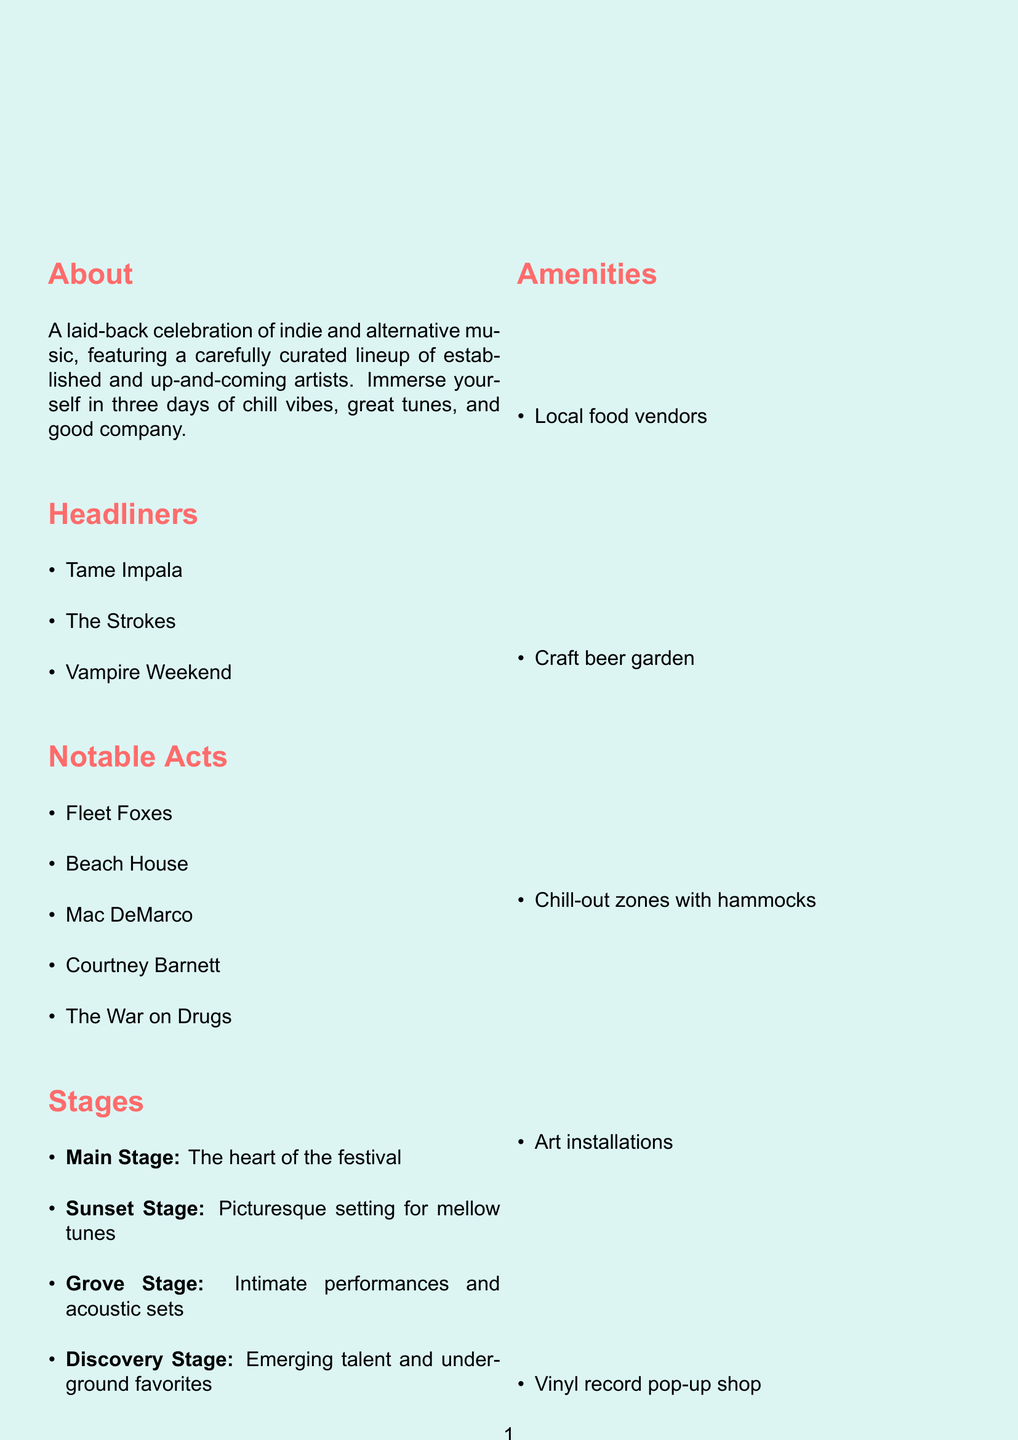what are the dates of the festival? The festival takes place from August 15-17, 2023.
Answer: August 15-17, 2023 what is the location of the festival? The festival is held at Harmony Park, Austin, TX.
Answer: Harmony Park, Austin, TX who are the headliners? The main acts featured at the festival include Tame Impala, The Strokes, and Vampire Weekend.
Answer: Tame Impala, The Strokes, Vampire Weekend how many stages are there? There are four stages at the festival, as listed in the document.
Answer: Four what is the general ticket price? The general ticket price is provided in the document.
Answer: $199 what is an example of a sustainability initiative at the festival? Several sustainability initiatives are mentioned, one of which is the reusable cup program.
Answer: Reusable cup program which stage features intimate performances? The Grove Stage is described as perfect for intimate performances and acoustic sets.
Answer: Grove Stage what amenities can attendees expect? Attendees can enjoy various amenities, including local food vendors and a craft beer garden.
Answer: Local food vendors, craft beer garden why is the festival described as laid-back? The festival focuses on chill vibes, great tunes, and good company, which contributes to its laid-back atmosphere.
Answer: Chill vibes, great tunes, good company 